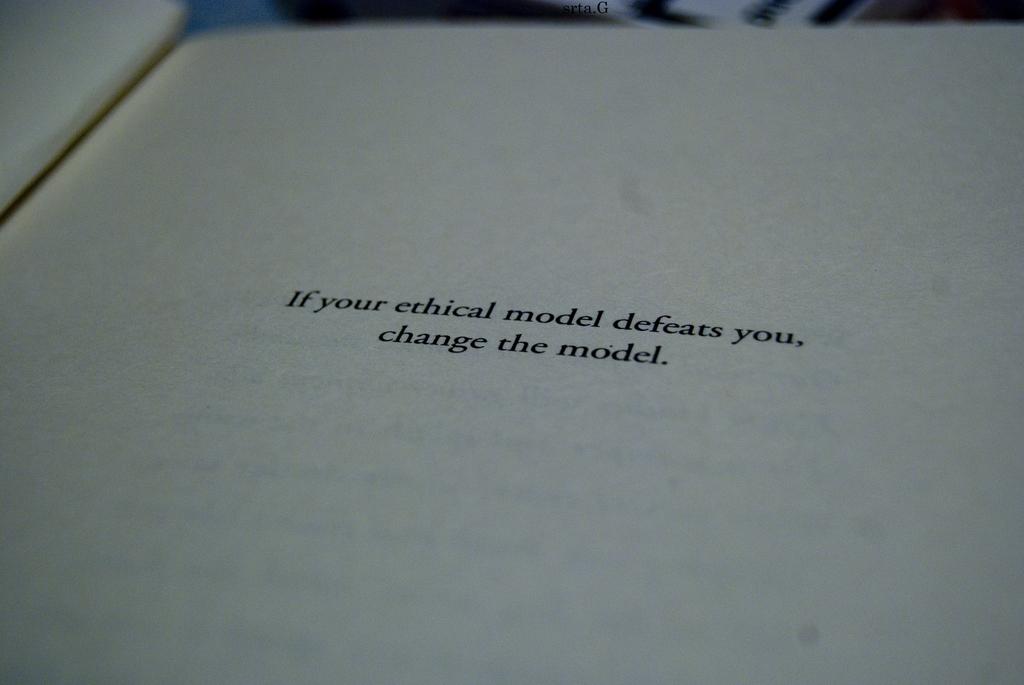What should you do if the model defeats you?
Give a very brief answer. Change the model. 